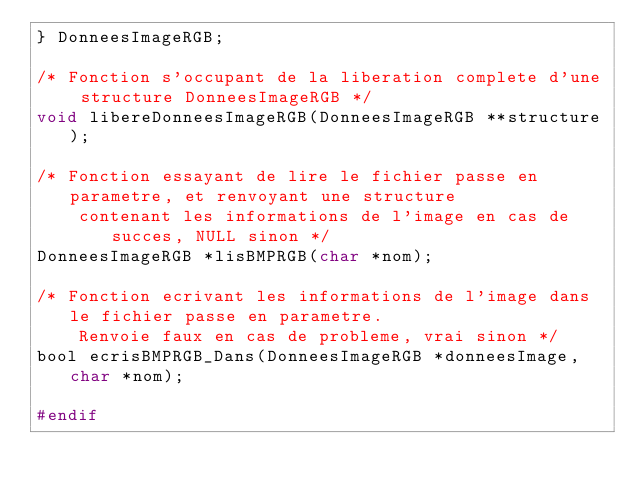<code> <loc_0><loc_0><loc_500><loc_500><_C_>} DonneesImageRGB;

/* Fonction s'occupant de la liberation complete d'une structure DonneesImageRGB */
void libereDonneesImageRGB(DonneesImageRGB **structure);

/* Fonction essayant de lire le fichier passe en parametre, et renvoyant une structure
	contenant les informations de l'image en cas de succes, NULL sinon */
DonneesImageRGB *lisBMPRGB(char *nom);

/* Fonction ecrivant les informations de l'image dans le fichier passe en parametre.
	Renvoie faux en cas de probleme, vrai sinon */
bool ecrisBMPRGB_Dans(DonneesImageRGB *donneesImage, char *nom);

#endif
</code> 